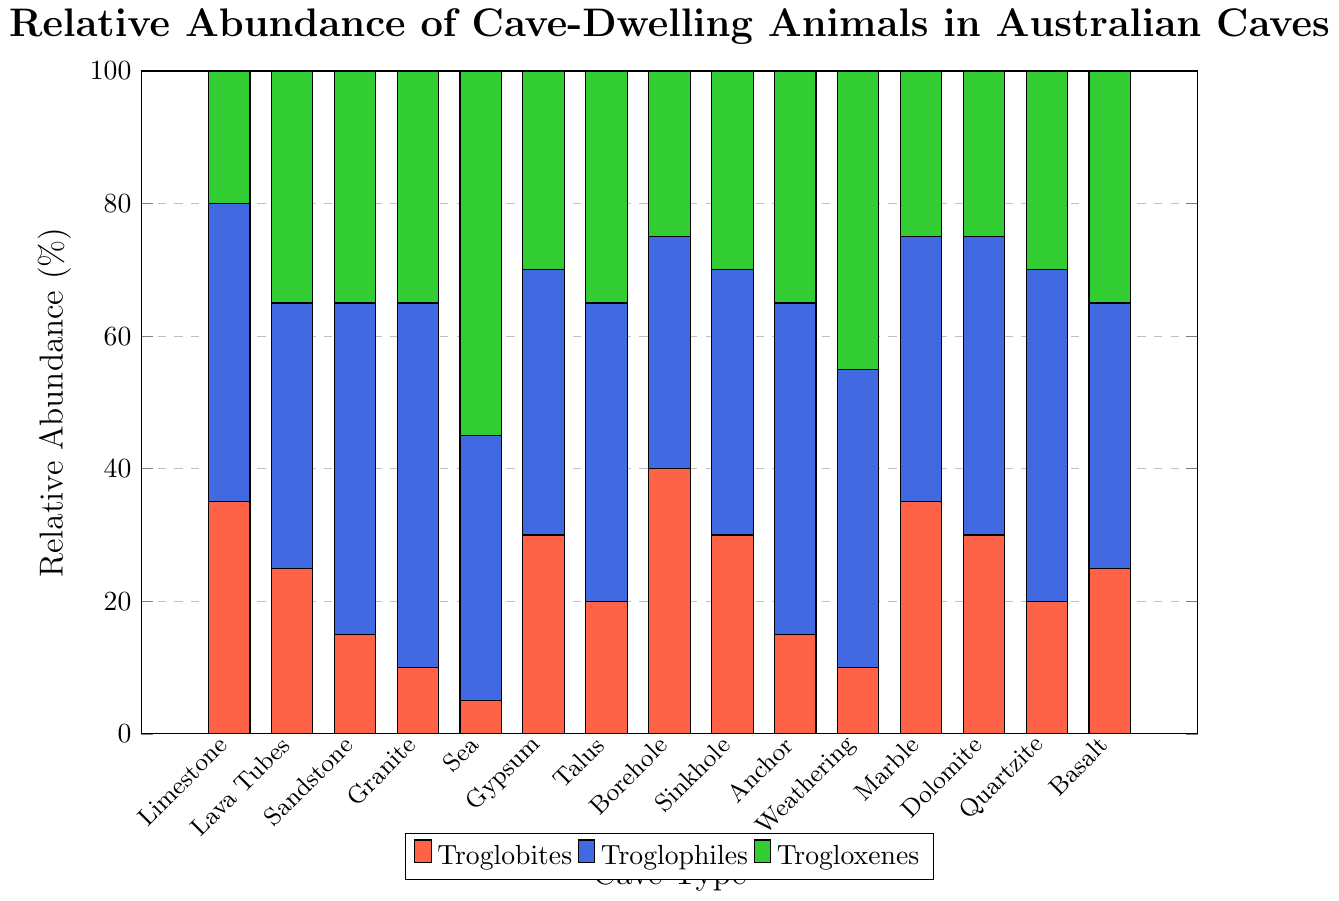What is the sum of the relative abundance of troglobites, troglophiles, and trogloxenes in Sandstone Caves? First, identify the values for Sandstone Caves: Troglobites (15), Troglophiles (50), and Trogloxenes (35). Then, sum these values: 15 + 50 + 35 = 100.
Answer: 100 Which cave type has the highest relative abundance of troglophiles? From the figure, observe that Granite Caves have the highest value for troglophiles, which is 55%.
Answer: Granite Caves In which cave type is the relative abundance of troglobites equal to that of trogloxenes? Identify the cave types where the values for troglobites and trogloxenes are the same. For Borehole Caves, both values are equal to 25%.
Answer: Borehole Caves What is the relative abundance difference between troglophiles and trogloxenes in Sea Caves? Identify the values for Sea Caves: Troglophiles (40) and Trogloxenes (55). Compute the difference: 55 - 40 = 15.
Answer: 15 Which cave type has the least relative abundance of troglobites? From the figure, Sea Caves have the least relative abundance of troglobites, which is 5%.
Answer: Sea Caves What is the average relative abundance of troglobites across all cave types? Sum the troglobite values: 35 + 25 + 15 + 10 + 5 + 30 + 20 + 40 + 30 + 15 + 10 + 35 + 30 + 20 + 25 = 365. There are 15 cave types, so the average is 365/15 = 24.33.
Answer: 24.33 Which cave type has the highest combined relative abundance of troglobites and troglophiles? Identify the combined values for each cave type, then compare. For Limestone Caves: 35 (troglobites) + 45 (troglophiles) = 80. Repeat for each cave type; the highest combined value is 65 (Granite Caves' (10+55)).
Answer: Granite Caves Is the relative abundance of trogloxenes higher than troglophiles in any cave type? If yes, in which cave type(s)? Compare the values: for Weathering Caves, trogloxenes (45) is higher than troglophiles (45) but this does not apply for a higher trogloxene value. However, in Sea Caves, trogloxenes (55) exceeds troglophiles (40).
Answer: Sea Caves 